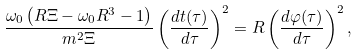Convert formula to latex. <formula><loc_0><loc_0><loc_500><loc_500>\frac { \omega _ { 0 } \left ( R \Xi - \omega _ { 0 } R ^ { 3 } - 1 \right ) } { m ^ { 2 } \Xi } \left ( \frac { d t ( \tau ) } { d \tau } \right ) ^ { 2 } = R \left ( \frac { d \varphi ( \tau ) } { d \tau } \right ) ^ { 2 } ,</formula> 